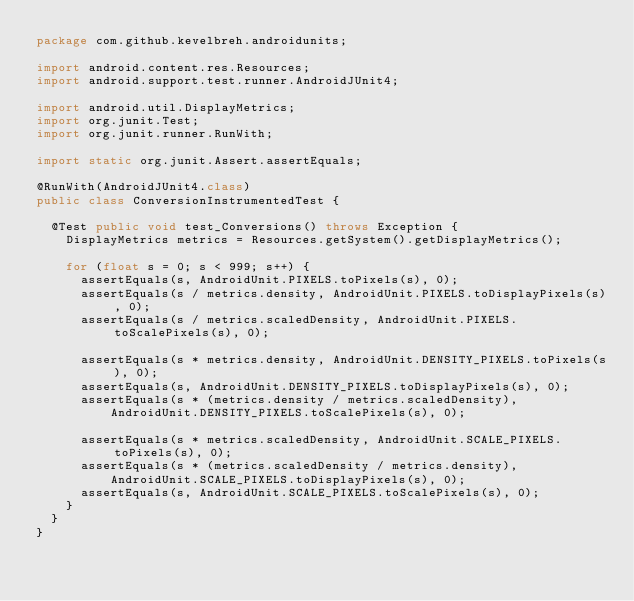Convert code to text. <code><loc_0><loc_0><loc_500><loc_500><_Java_>package com.github.kevelbreh.androidunits;

import android.content.res.Resources;
import android.support.test.runner.AndroidJUnit4;

import android.util.DisplayMetrics;
import org.junit.Test;
import org.junit.runner.RunWith;

import static org.junit.Assert.assertEquals;

@RunWith(AndroidJUnit4.class)
public class ConversionInstrumentedTest {

  @Test public void test_Conversions() throws Exception {
    DisplayMetrics metrics = Resources.getSystem().getDisplayMetrics();

    for (float s = 0; s < 999; s++) {
      assertEquals(s, AndroidUnit.PIXELS.toPixels(s), 0);
      assertEquals(s / metrics.density, AndroidUnit.PIXELS.toDisplayPixels(s), 0);
      assertEquals(s / metrics.scaledDensity, AndroidUnit.PIXELS.toScalePixels(s), 0);

      assertEquals(s * metrics.density, AndroidUnit.DENSITY_PIXELS.toPixels(s), 0);
      assertEquals(s, AndroidUnit.DENSITY_PIXELS.toDisplayPixels(s), 0);
      assertEquals(s * (metrics.density / metrics.scaledDensity),
          AndroidUnit.DENSITY_PIXELS.toScalePixels(s), 0);

      assertEquals(s * metrics.scaledDensity, AndroidUnit.SCALE_PIXELS.toPixels(s), 0);
      assertEquals(s * (metrics.scaledDensity / metrics.density),
          AndroidUnit.SCALE_PIXELS.toDisplayPixels(s), 0);
      assertEquals(s, AndroidUnit.SCALE_PIXELS.toScalePixels(s), 0);
    }
  }
}
</code> 